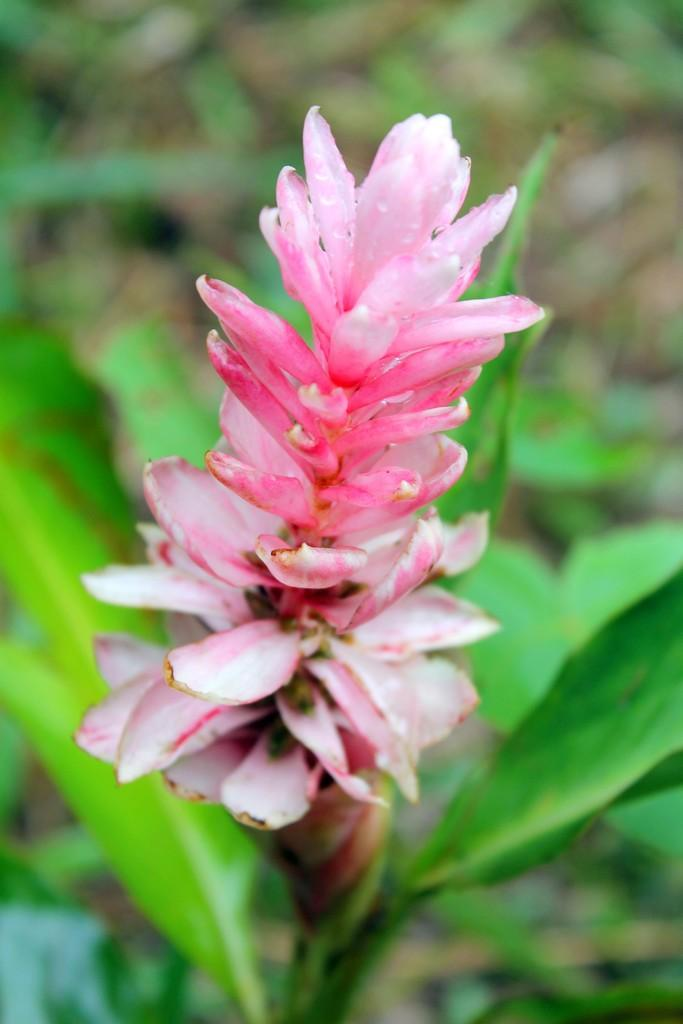What is the main subject of the image? There is a flower in the image. Can you describe the color of the flower? The flower is pink in color. What can be seen in the background of the image? The background of the image is green. What type of wound can be seen on the flower in the image? There is no wound present on the flower in the image. Is the flower being used to play volleyball in the image? There is no volleyball or any indication of a game being played in the image. 